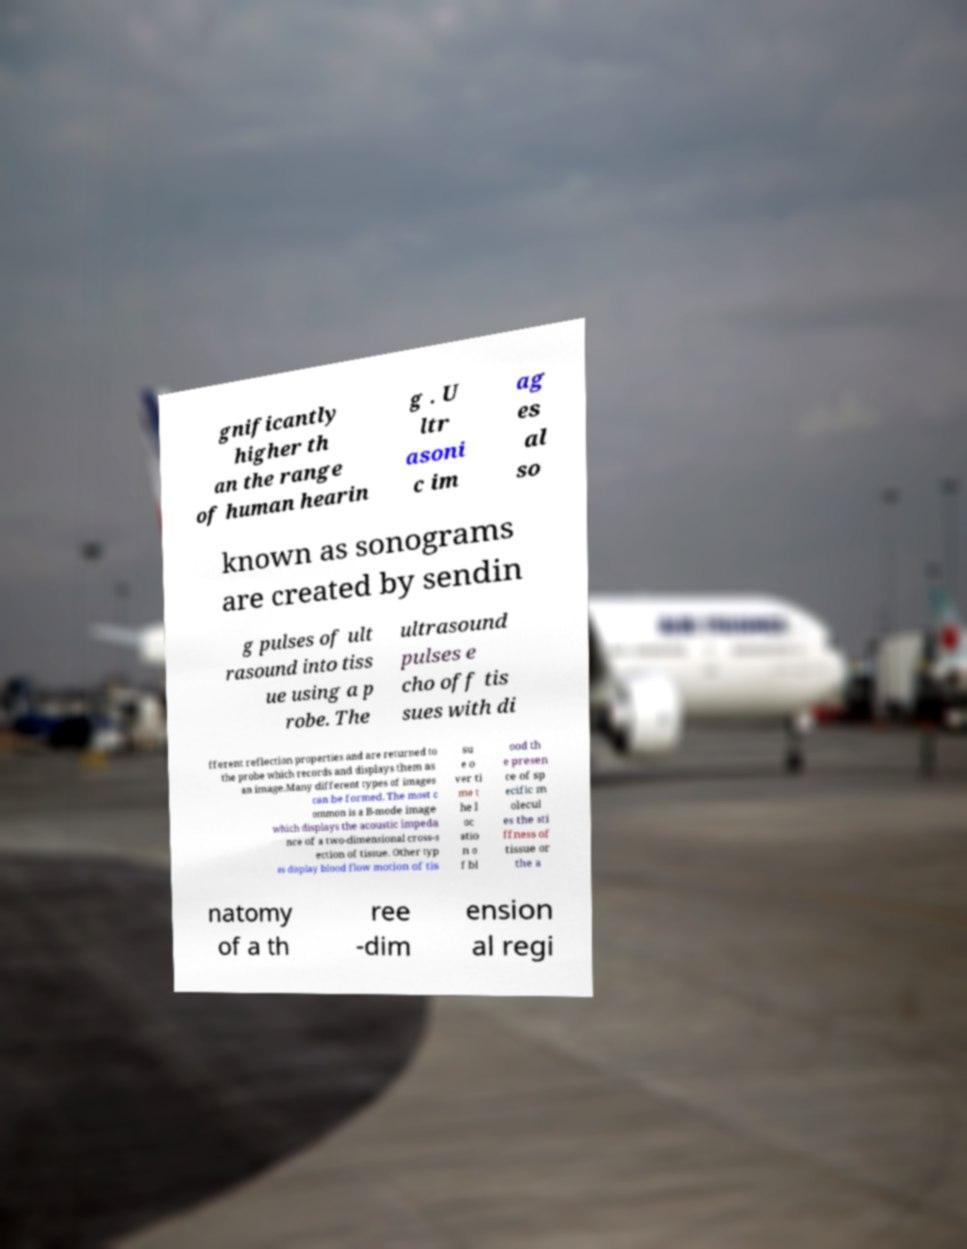Can you accurately transcribe the text from the provided image for me? gnificantly higher th an the range of human hearin g . U ltr asoni c im ag es al so known as sonograms are created by sendin g pulses of ult rasound into tiss ue using a p robe. The ultrasound pulses e cho off tis sues with di fferent reflection properties and are returned to the probe which records and displays them as an image.Many different types of images can be formed. The most c ommon is a B-mode image which displays the acoustic impeda nce of a two-dimensional cross-s ection of tissue. Other typ es display blood flow motion of tis su e o ver ti me t he l oc atio n o f bl ood th e presen ce of sp ecific m olecul es the sti ffness of tissue or the a natomy of a th ree -dim ension al regi 